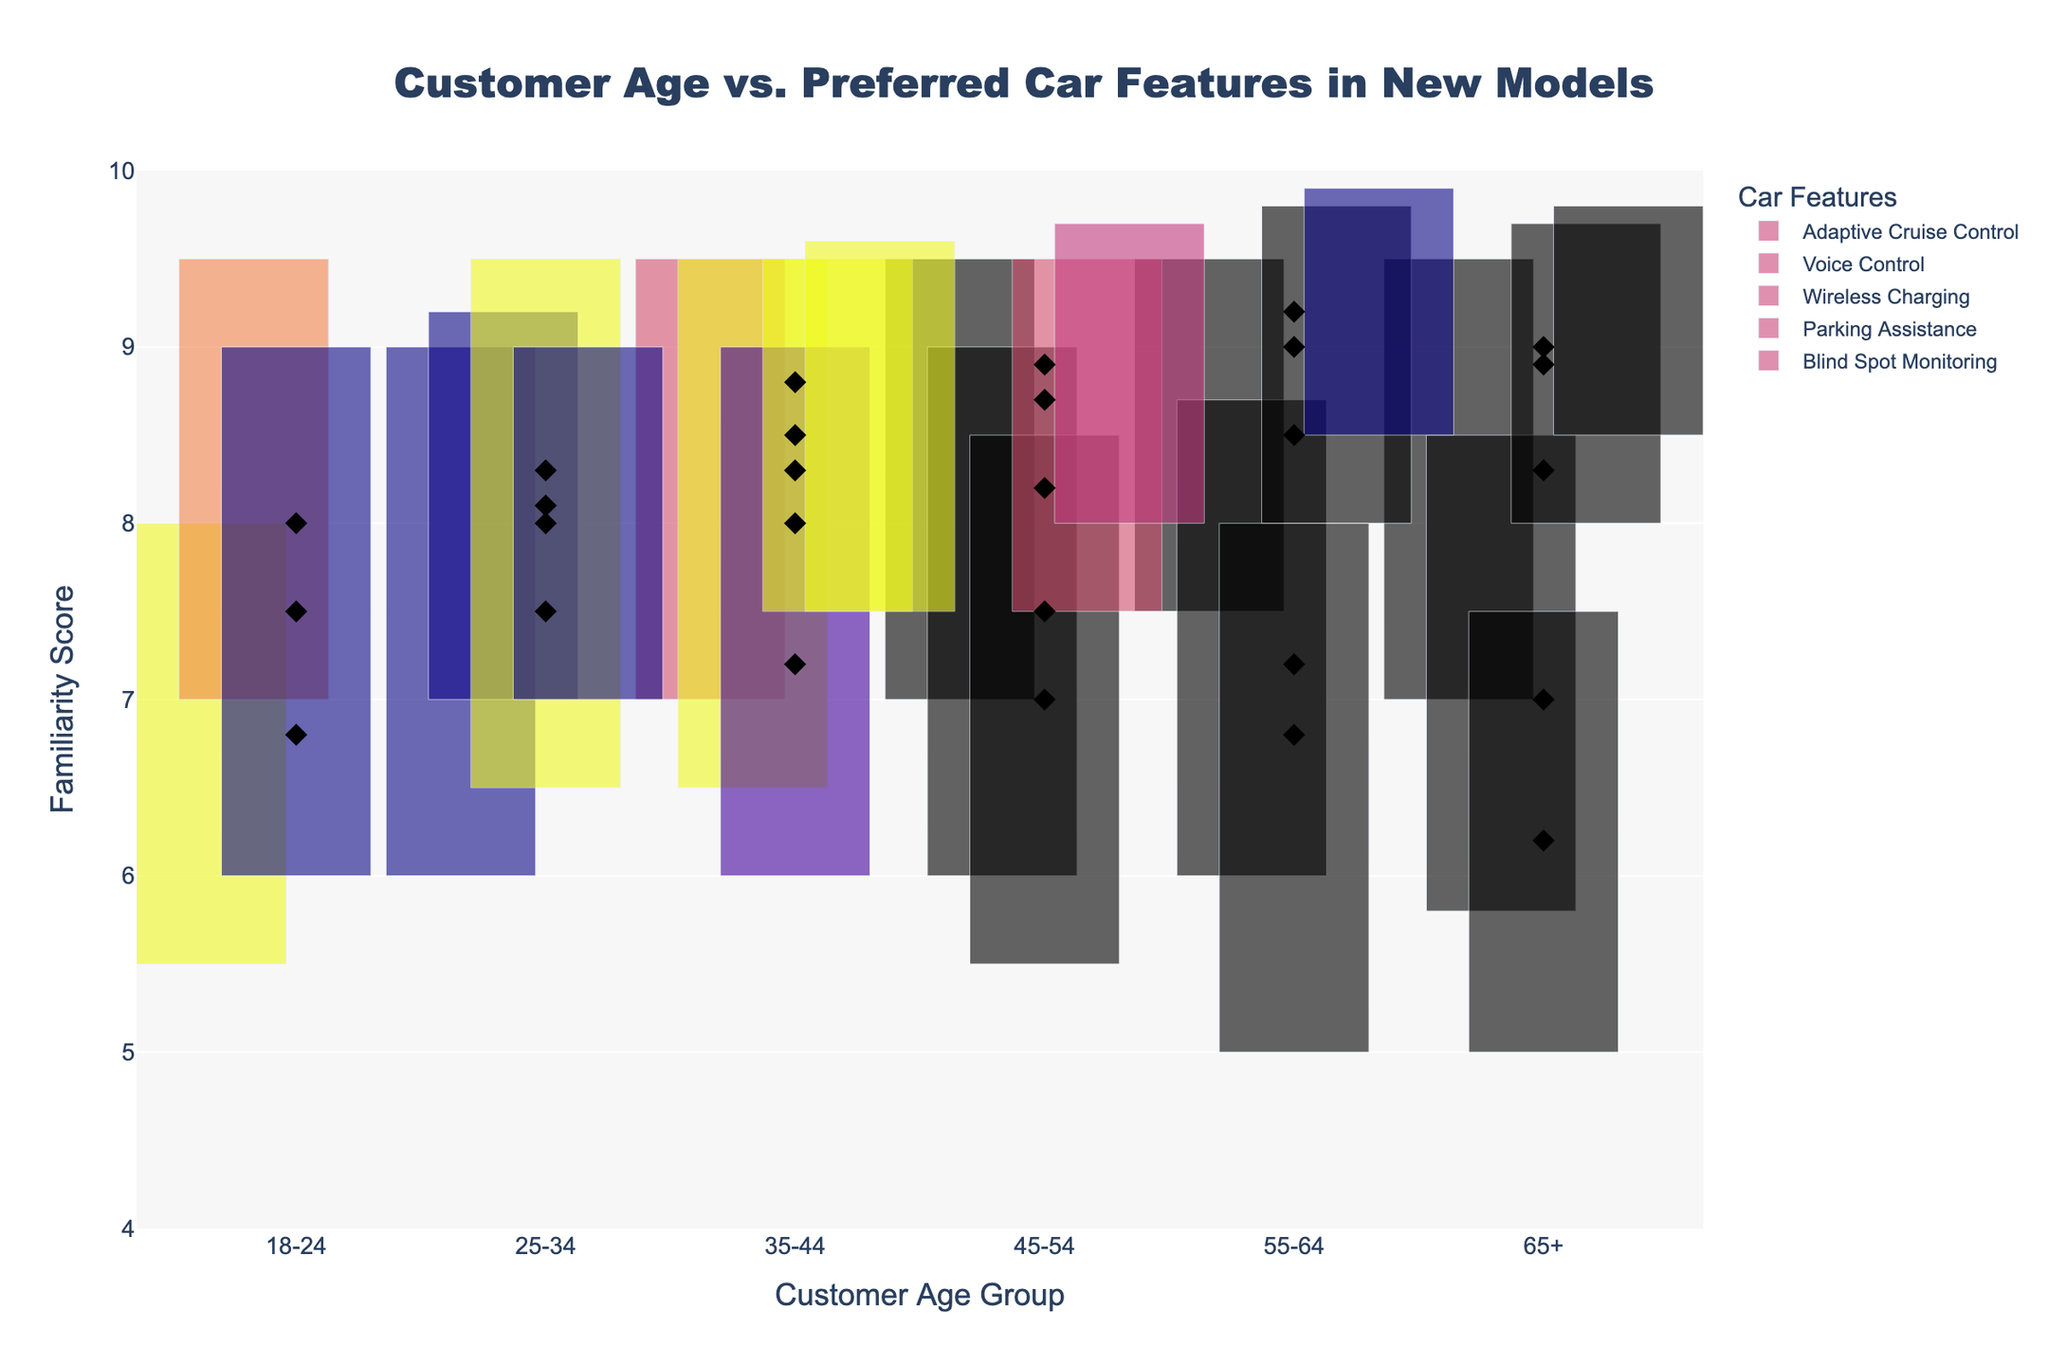What is the title of the figure? The title is often prominently displayed at the top of the figure in large font. It provides a summary of what the figure is about.
Answer: Customer Age vs. Preferred Car Features in New Models Which car feature has the highest average familiarity score for the 55-64 age group? Look for the data points representing average scores (black diamonds) within the section for the 55-64 age group and identify the highest point.
Answer: Blind Spot Monitoring How many features are plotted for the 25-34 age group? Count the number of distinct features listed along the Customer Age category 25-34. Each feature has its separate plot within this age group.
Answer: 4 Which age group has the lowest minimum score for Wireless Charging? Identify the lowest point on the range bar for Wireless Charging across all age groups. The age group corresponding to this point has the lowest minimum score.
Answer: 65+ What is the range of familiarity scores for Adaptive Cruise Control in the 18-24 age group? The range is found by subtracting the minimum score from the maximum score for Adaptive Cruise Control within the 18-24 age group.
Answer: 2.5 Which car feature shows the widest range of scores in the 45-54 age group? Identify the length of the range bar for each feature within the 45-54 age group. The feature with the longest range bar denotes the widest range of scores.
Answer: Wireless Charging Compare the average scores of Voice Control between the 25-34 and 35-44 age groups. Which one is higher? Look at the average score points (black diamonds) for Voice Control in the 25-34 and 35-44 age groups. Compare these values to determine the higher score.
Answer: 25-34 What is the average familiarity score of Parking Assistance for customers aged 55-64? Locate the black diamond representing the average score for Parking Assistance in the 55-64 age group. The position of this diamond along the y-axis gives the average score.
Answer: 9.0 Which age group shows the smallest difference between the average and maximum scores for Blind Spot Monitoring? Calculate the difference between the maximum and average scores for Blind Spot Monitoring for each age group, and identify the group with the smallest difference.
Answer: 55-64 What is the maximum score for Voice Control in the 65+ age group? Identify the top of the range bar for Voice Control within the 65+ age group along the y-axis to find the maximum score.
Answer: 8.5 